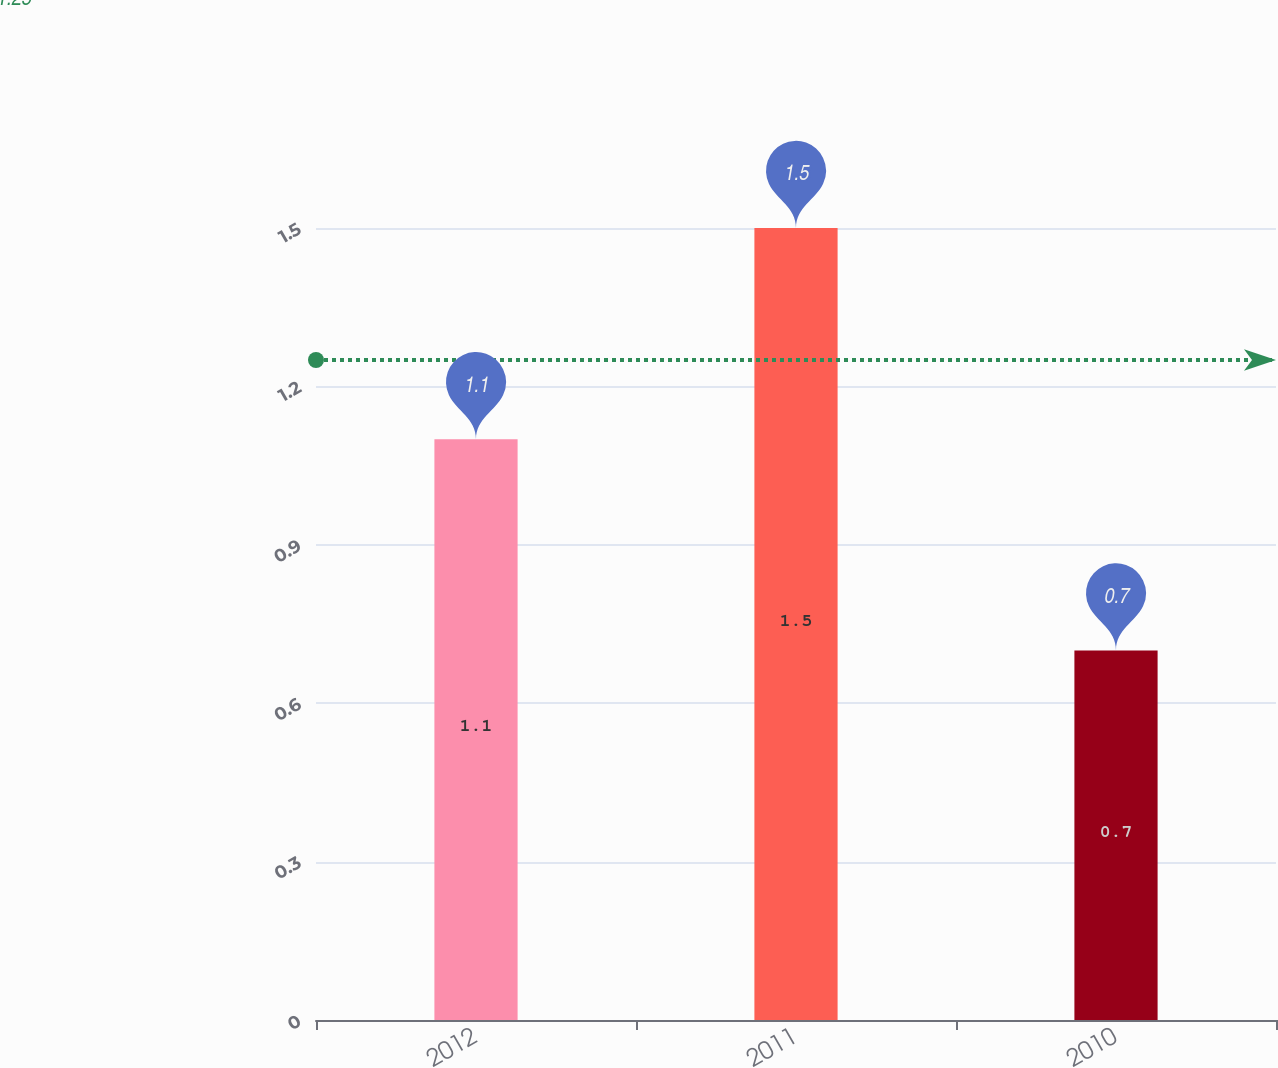<chart> <loc_0><loc_0><loc_500><loc_500><bar_chart><fcel>2012<fcel>2011<fcel>2010<nl><fcel>1.1<fcel>1.5<fcel>0.7<nl></chart> 